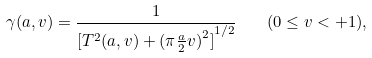<formula> <loc_0><loc_0><loc_500><loc_500>\gamma ( a , v ) = \frac { 1 } { { [ T ^ { 2 } ( a , v ) + { ( \pi \frac { a } { 2 } v ) } ^ { 2 } ] } ^ { 1 / 2 } } \quad ( 0 \leq v < + 1 ) ,</formula> 